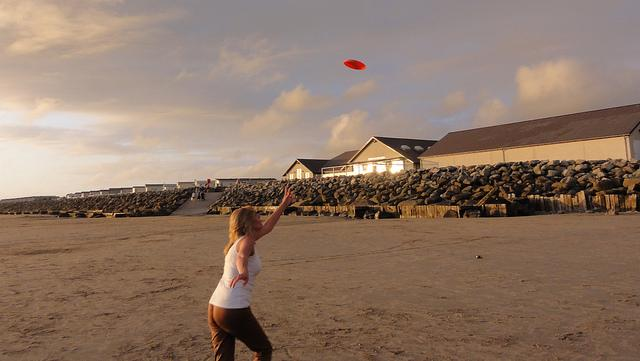What cut of shirt is she wearing? tank top 